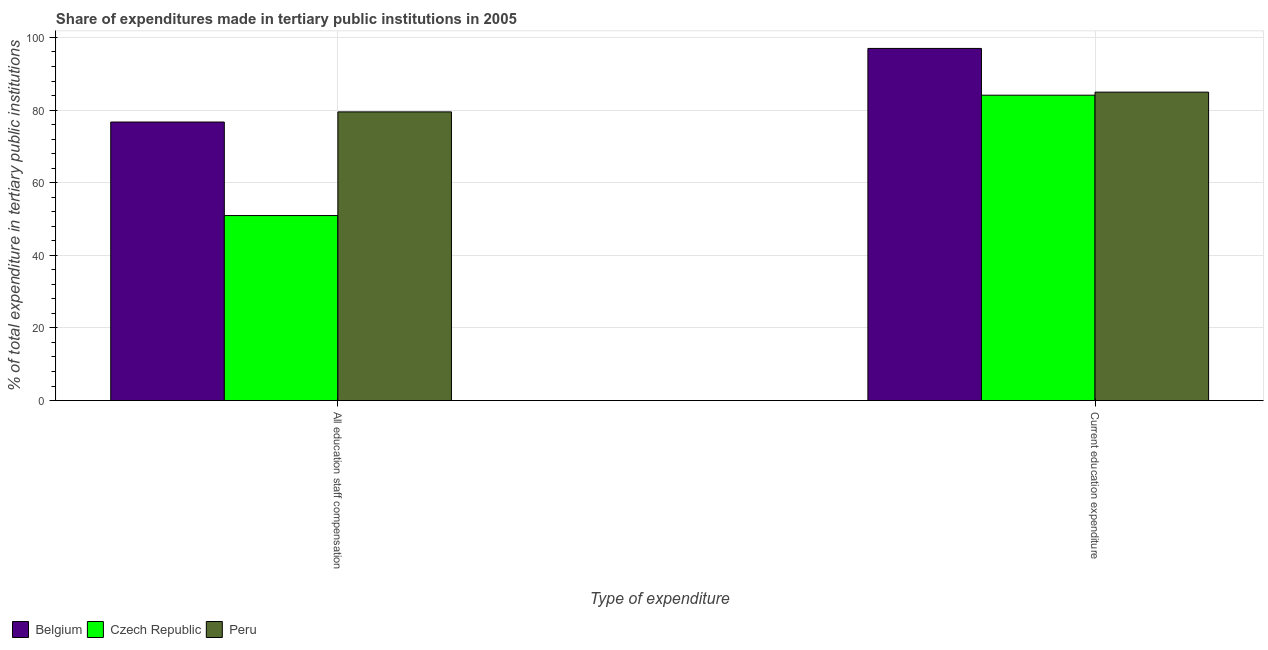How many different coloured bars are there?
Keep it short and to the point. 3. How many groups of bars are there?
Ensure brevity in your answer.  2. Are the number of bars per tick equal to the number of legend labels?
Give a very brief answer. Yes. How many bars are there on the 1st tick from the left?
Provide a short and direct response. 3. How many bars are there on the 2nd tick from the right?
Your response must be concise. 3. What is the label of the 1st group of bars from the left?
Provide a short and direct response. All education staff compensation. What is the expenditure in education in Belgium?
Offer a very short reply. 96.97. Across all countries, what is the maximum expenditure in staff compensation?
Provide a short and direct response. 79.5. Across all countries, what is the minimum expenditure in staff compensation?
Give a very brief answer. 50.95. In which country was the expenditure in staff compensation minimum?
Your answer should be very brief. Czech Republic. What is the total expenditure in staff compensation in the graph?
Offer a terse response. 207.15. What is the difference between the expenditure in staff compensation in Czech Republic and that in Belgium?
Offer a terse response. -25.76. What is the difference between the expenditure in education in Belgium and the expenditure in staff compensation in Czech Republic?
Provide a short and direct response. 46.02. What is the average expenditure in education per country?
Offer a terse response. 88.67. What is the difference between the expenditure in staff compensation and expenditure in education in Peru?
Ensure brevity in your answer.  -5.44. What is the ratio of the expenditure in education in Czech Republic to that in Peru?
Your response must be concise. 0.99. Is the expenditure in staff compensation in Peru less than that in Czech Republic?
Offer a very short reply. No. What does the 2nd bar from the left in All education staff compensation represents?
Your answer should be compact. Czech Republic. What does the 1st bar from the right in Current education expenditure represents?
Provide a succinct answer. Peru. Are the values on the major ticks of Y-axis written in scientific E-notation?
Your answer should be compact. No. Where does the legend appear in the graph?
Provide a short and direct response. Bottom left. How are the legend labels stacked?
Provide a short and direct response. Horizontal. What is the title of the graph?
Ensure brevity in your answer.  Share of expenditures made in tertiary public institutions in 2005. What is the label or title of the X-axis?
Ensure brevity in your answer.  Type of expenditure. What is the label or title of the Y-axis?
Provide a short and direct response. % of total expenditure in tertiary public institutions. What is the % of total expenditure in tertiary public institutions of Belgium in All education staff compensation?
Ensure brevity in your answer.  76.71. What is the % of total expenditure in tertiary public institutions in Czech Republic in All education staff compensation?
Your answer should be very brief. 50.95. What is the % of total expenditure in tertiary public institutions in Peru in All education staff compensation?
Your answer should be very brief. 79.5. What is the % of total expenditure in tertiary public institutions in Belgium in Current education expenditure?
Offer a very short reply. 96.97. What is the % of total expenditure in tertiary public institutions of Czech Republic in Current education expenditure?
Offer a very short reply. 84.09. What is the % of total expenditure in tertiary public institutions in Peru in Current education expenditure?
Offer a very short reply. 84.94. Across all Type of expenditure, what is the maximum % of total expenditure in tertiary public institutions in Belgium?
Provide a short and direct response. 96.97. Across all Type of expenditure, what is the maximum % of total expenditure in tertiary public institutions of Czech Republic?
Your response must be concise. 84.09. Across all Type of expenditure, what is the maximum % of total expenditure in tertiary public institutions of Peru?
Ensure brevity in your answer.  84.94. Across all Type of expenditure, what is the minimum % of total expenditure in tertiary public institutions in Belgium?
Offer a very short reply. 76.71. Across all Type of expenditure, what is the minimum % of total expenditure in tertiary public institutions of Czech Republic?
Your response must be concise. 50.95. Across all Type of expenditure, what is the minimum % of total expenditure in tertiary public institutions of Peru?
Provide a succinct answer. 79.5. What is the total % of total expenditure in tertiary public institutions of Belgium in the graph?
Your answer should be very brief. 173.68. What is the total % of total expenditure in tertiary public institutions in Czech Republic in the graph?
Give a very brief answer. 135.04. What is the total % of total expenditure in tertiary public institutions in Peru in the graph?
Provide a succinct answer. 164.43. What is the difference between the % of total expenditure in tertiary public institutions in Belgium in All education staff compensation and that in Current education expenditure?
Provide a short and direct response. -20.26. What is the difference between the % of total expenditure in tertiary public institutions in Czech Republic in All education staff compensation and that in Current education expenditure?
Keep it short and to the point. -33.14. What is the difference between the % of total expenditure in tertiary public institutions in Peru in All education staff compensation and that in Current education expenditure?
Your response must be concise. -5.44. What is the difference between the % of total expenditure in tertiary public institutions in Belgium in All education staff compensation and the % of total expenditure in tertiary public institutions in Czech Republic in Current education expenditure?
Your response must be concise. -7.39. What is the difference between the % of total expenditure in tertiary public institutions of Belgium in All education staff compensation and the % of total expenditure in tertiary public institutions of Peru in Current education expenditure?
Ensure brevity in your answer.  -8.23. What is the difference between the % of total expenditure in tertiary public institutions of Czech Republic in All education staff compensation and the % of total expenditure in tertiary public institutions of Peru in Current education expenditure?
Your answer should be very brief. -33.99. What is the average % of total expenditure in tertiary public institutions of Belgium per Type of expenditure?
Provide a succinct answer. 86.84. What is the average % of total expenditure in tertiary public institutions in Czech Republic per Type of expenditure?
Your response must be concise. 67.52. What is the average % of total expenditure in tertiary public institutions of Peru per Type of expenditure?
Give a very brief answer. 82.22. What is the difference between the % of total expenditure in tertiary public institutions in Belgium and % of total expenditure in tertiary public institutions in Czech Republic in All education staff compensation?
Provide a short and direct response. 25.76. What is the difference between the % of total expenditure in tertiary public institutions of Belgium and % of total expenditure in tertiary public institutions of Peru in All education staff compensation?
Your answer should be compact. -2.79. What is the difference between the % of total expenditure in tertiary public institutions in Czech Republic and % of total expenditure in tertiary public institutions in Peru in All education staff compensation?
Ensure brevity in your answer.  -28.55. What is the difference between the % of total expenditure in tertiary public institutions of Belgium and % of total expenditure in tertiary public institutions of Czech Republic in Current education expenditure?
Provide a short and direct response. 12.88. What is the difference between the % of total expenditure in tertiary public institutions of Belgium and % of total expenditure in tertiary public institutions of Peru in Current education expenditure?
Give a very brief answer. 12.03. What is the difference between the % of total expenditure in tertiary public institutions of Czech Republic and % of total expenditure in tertiary public institutions of Peru in Current education expenditure?
Your response must be concise. -0.84. What is the ratio of the % of total expenditure in tertiary public institutions of Belgium in All education staff compensation to that in Current education expenditure?
Provide a succinct answer. 0.79. What is the ratio of the % of total expenditure in tertiary public institutions in Czech Republic in All education staff compensation to that in Current education expenditure?
Offer a very short reply. 0.61. What is the ratio of the % of total expenditure in tertiary public institutions in Peru in All education staff compensation to that in Current education expenditure?
Offer a terse response. 0.94. What is the difference between the highest and the second highest % of total expenditure in tertiary public institutions of Belgium?
Make the answer very short. 20.26. What is the difference between the highest and the second highest % of total expenditure in tertiary public institutions of Czech Republic?
Ensure brevity in your answer.  33.14. What is the difference between the highest and the second highest % of total expenditure in tertiary public institutions of Peru?
Make the answer very short. 5.44. What is the difference between the highest and the lowest % of total expenditure in tertiary public institutions in Belgium?
Your answer should be very brief. 20.26. What is the difference between the highest and the lowest % of total expenditure in tertiary public institutions of Czech Republic?
Your response must be concise. 33.14. What is the difference between the highest and the lowest % of total expenditure in tertiary public institutions of Peru?
Give a very brief answer. 5.44. 